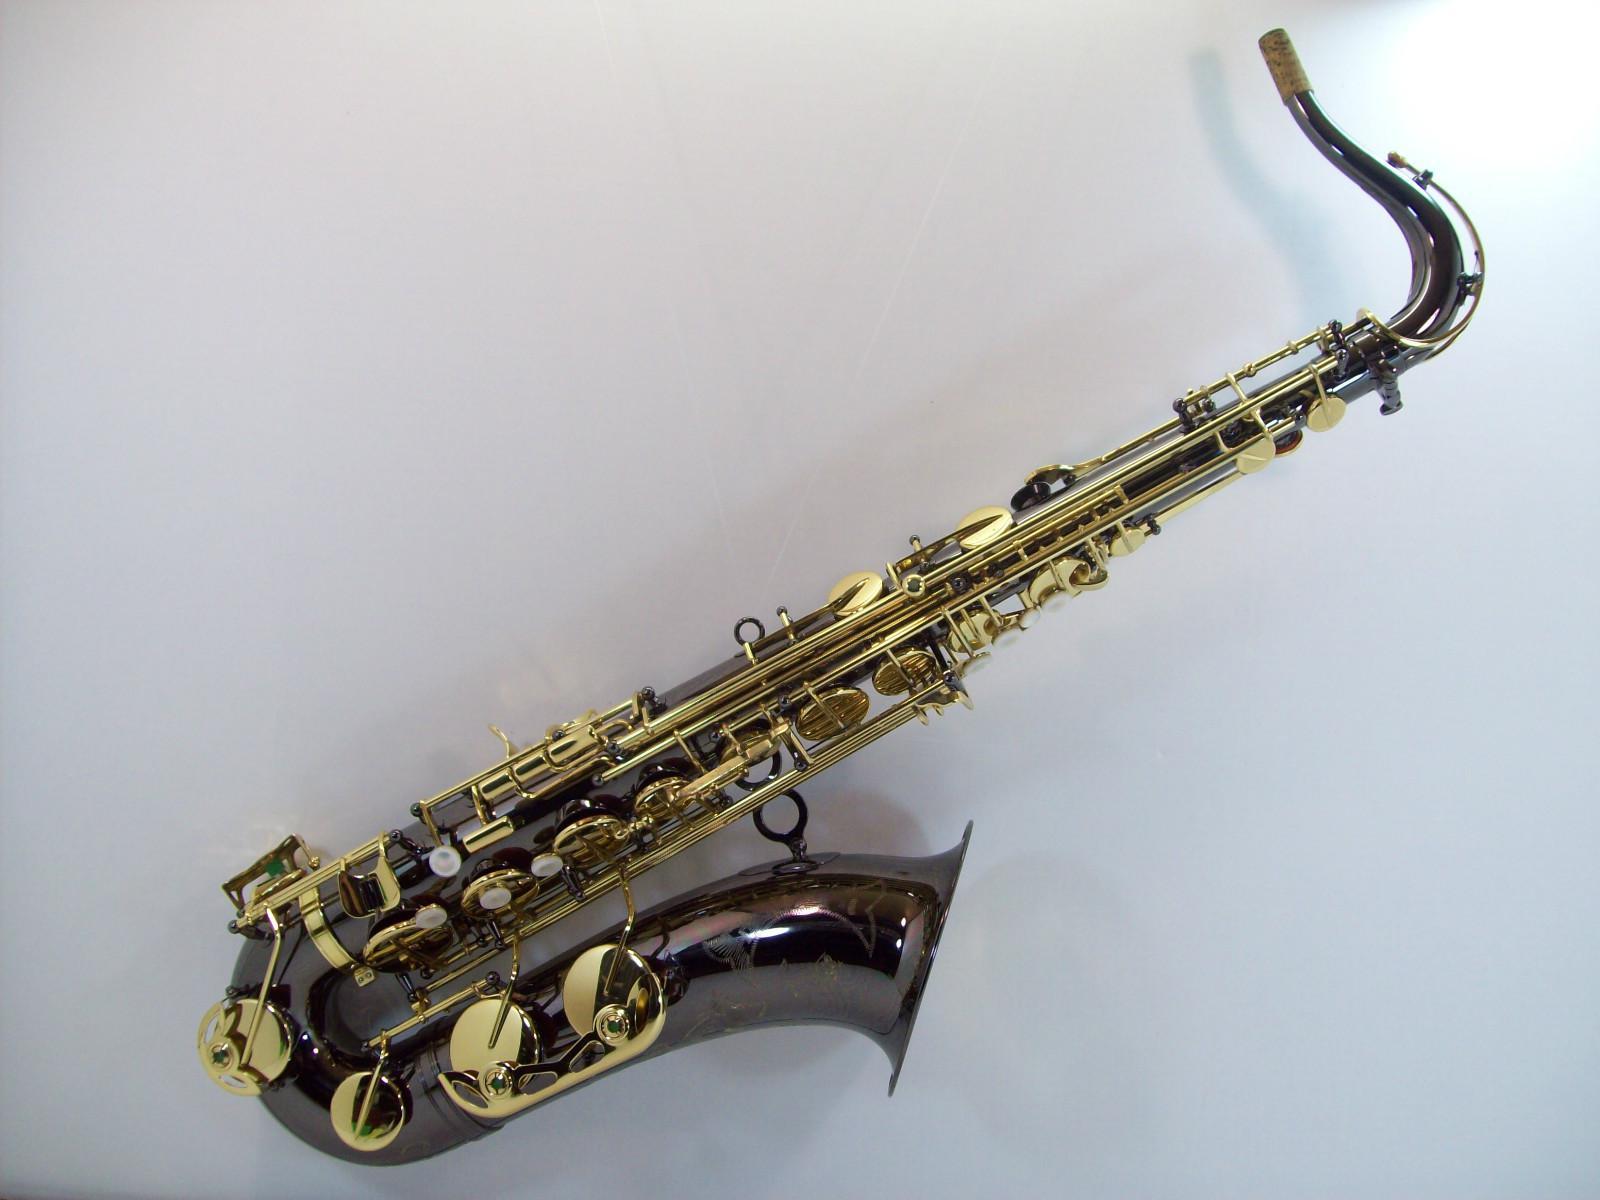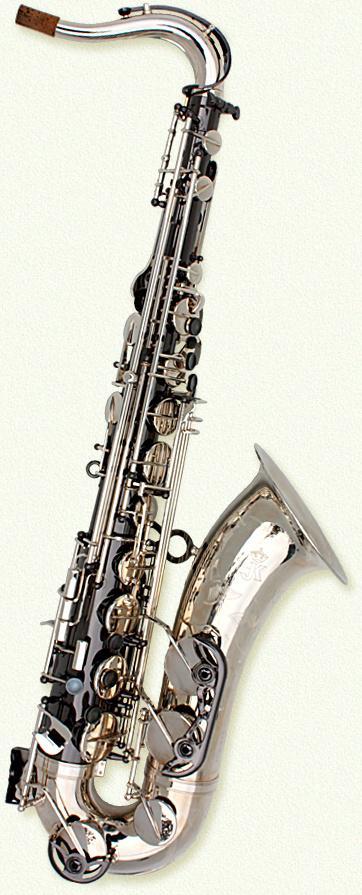The first image is the image on the left, the second image is the image on the right. Considering the images on both sides, is "In at least one image there is a single bras saxophone  with the mouth section tiped left froward with the horn part almost parrellal to the ground." valid? Answer yes or no. Yes. The first image is the image on the left, the second image is the image on the right. For the images shown, is this caption "Each saxophone is displayed nearly vertically with its bell facing rightward, but the saxophone on the right is a brighter, yellower gold color." true? Answer yes or no. No. 